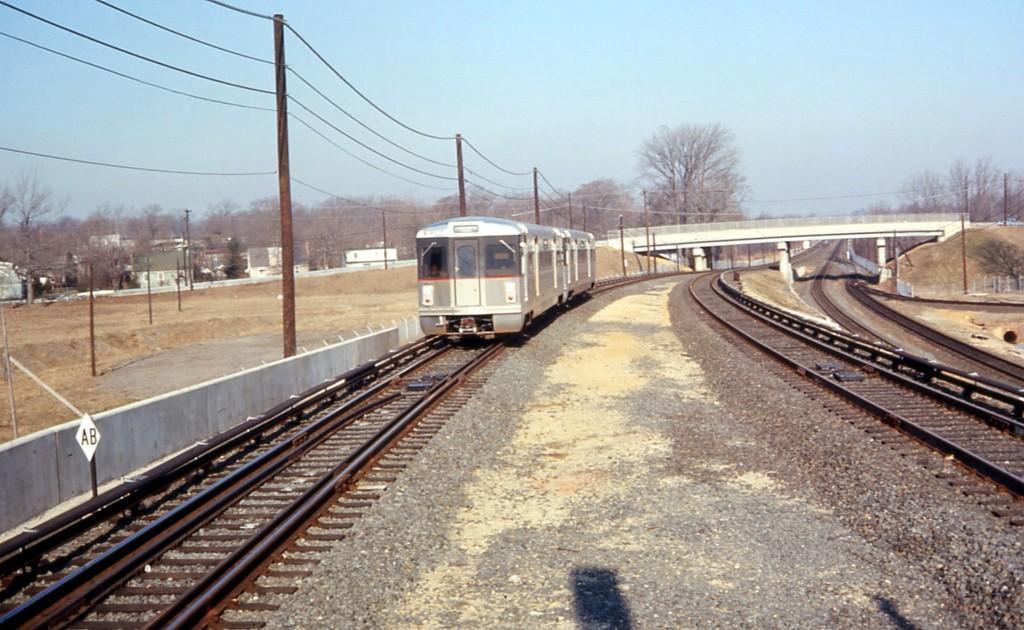Describe this image in one or two sentences. In this image I can see a train on a railway track. There are electric poles and wires on the left. There is a bridge at the back. There are trees at the back and sky at the top. 